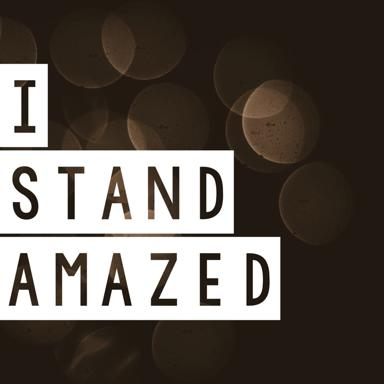How could this image be used effectively in a marketing campaign? This image could be effectively used in a marketing campaign that aims to evoke emotional reactions or highlight transformative experiences. Its message of 'I Stand Amazed' paired with its visually arresting backdrop can be strategically used to promote products or services related to personal development, luxury experiences, or anything intended to awe and inspire consumers. 